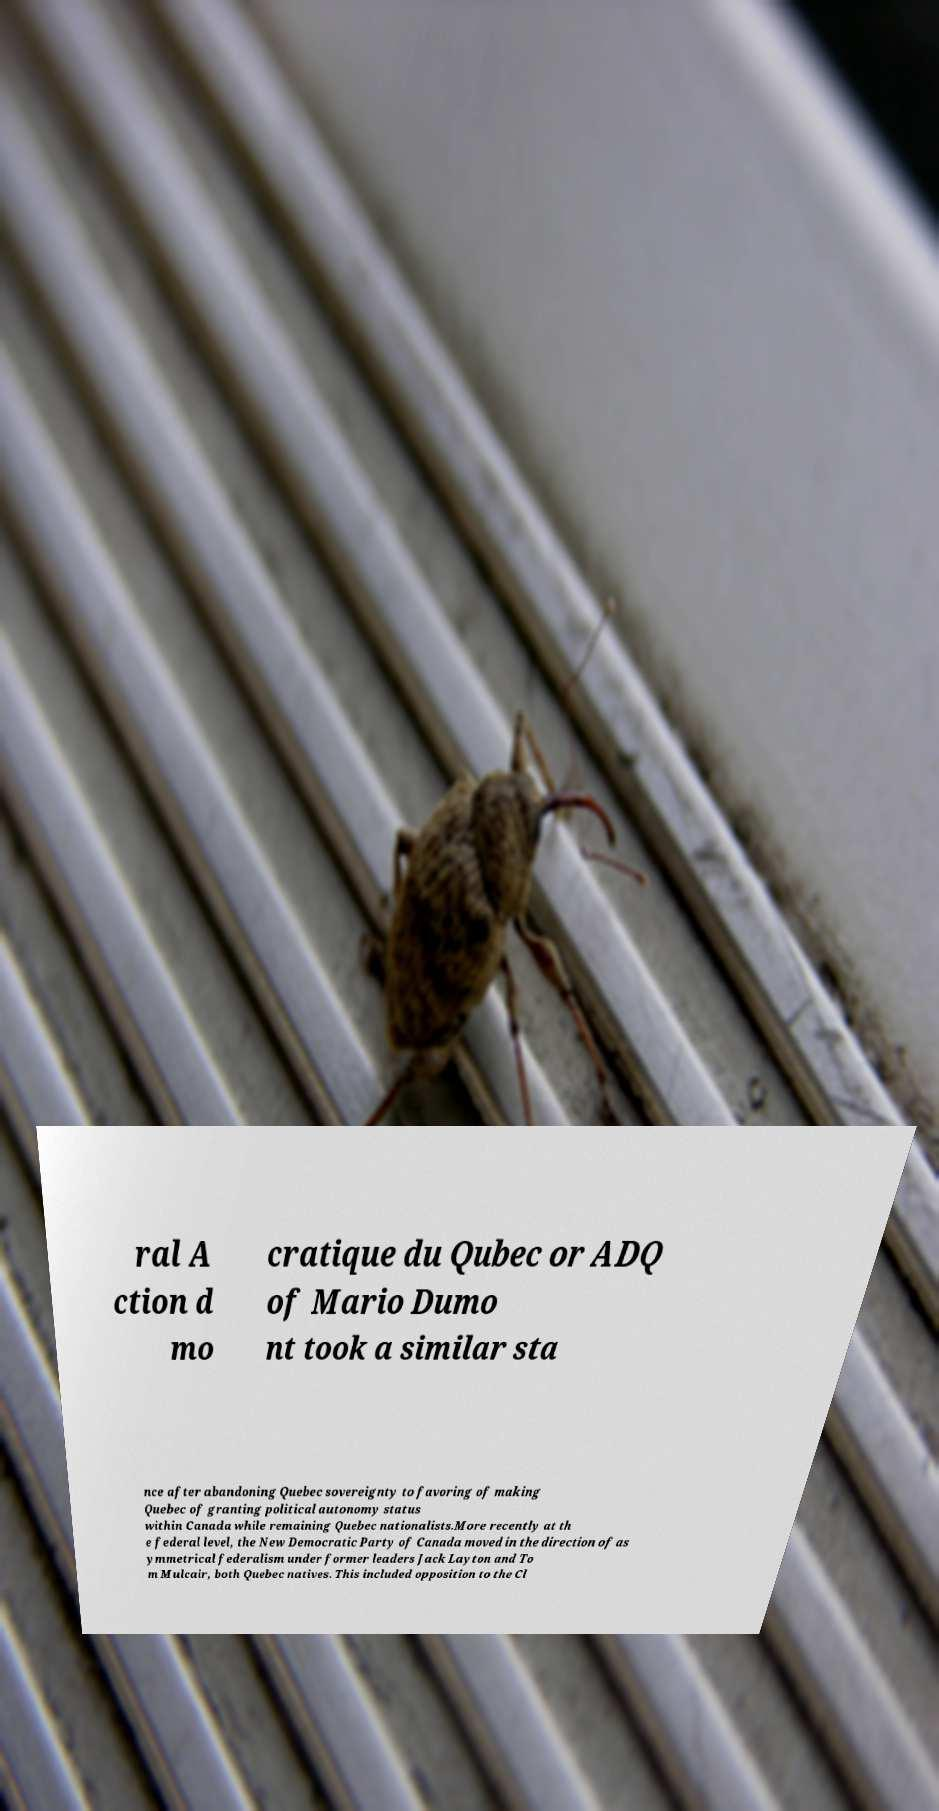Can you read and provide the text displayed in the image?This photo seems to have some interesting text. Can you extract and type it out for me? ral A ction d mo cratique du Qubec or ADQ of Mario Dumo nt took a similar sta nce after abandoning Quebec sovereignty to favoring of making Quebec of granting political autonomy status within Canada while remaining Quebec nationalists.More recently at th e federal level, the New Democratic Party of Canada moved in the direction of as ymmetrical federalism under former leaders Jack Layton and To m Mulcair, both Quebec natives. This included opposition to the Cl 